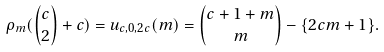Convert formula to latex. <formula><loc_0><loc_0><loc_500><loc_500>\rho _ { m } ( { { c } \choose { 2 } } + c ) = u _ { c , 0 , 2 c } ( m ) = { { c + 1 + m } \choose { m } } - \{ 2 c m + 1 \} .</formula> 